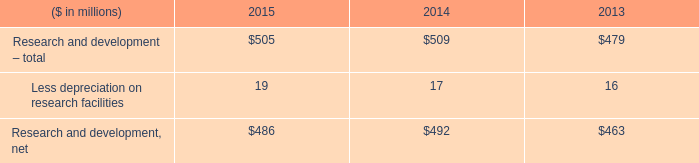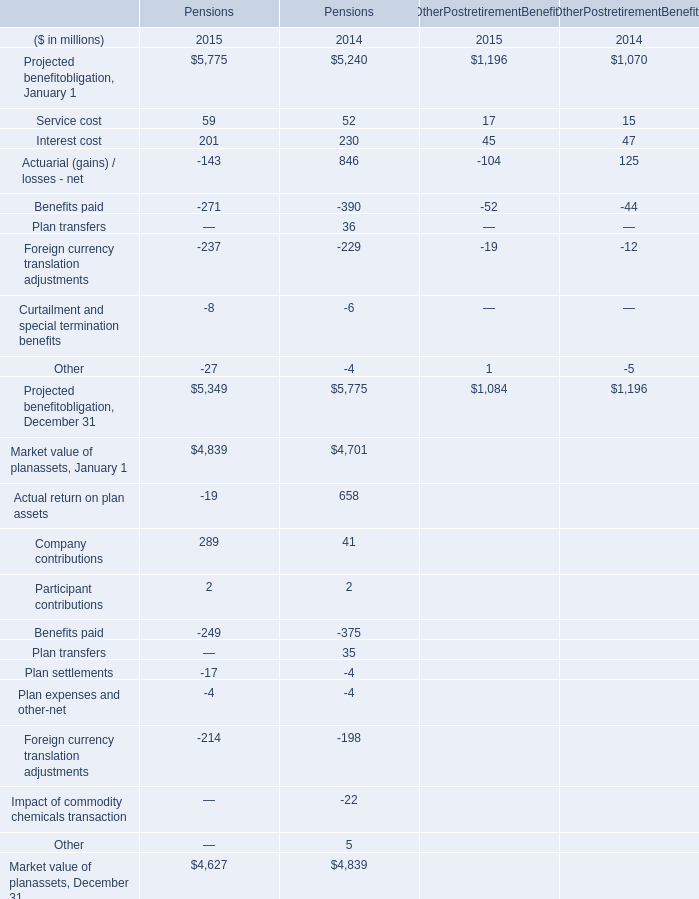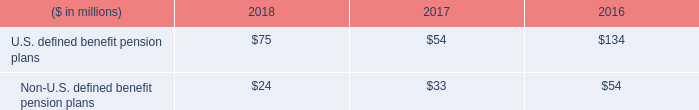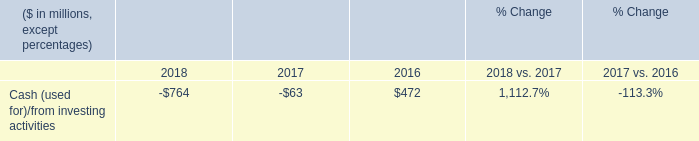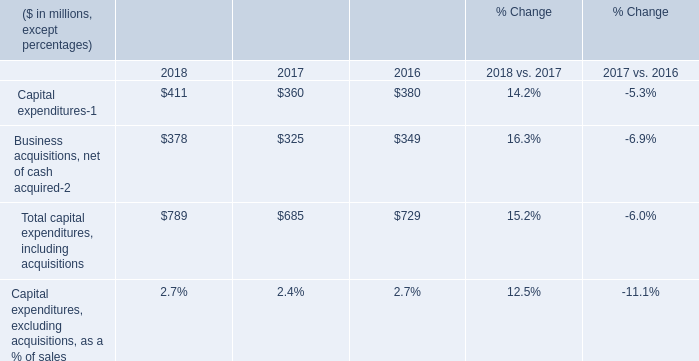what was the percentage change in research and development 2013 total from 2013 to 2014? 
Computations: ((509 - 479) / 479)
Answer: 0.06263. 